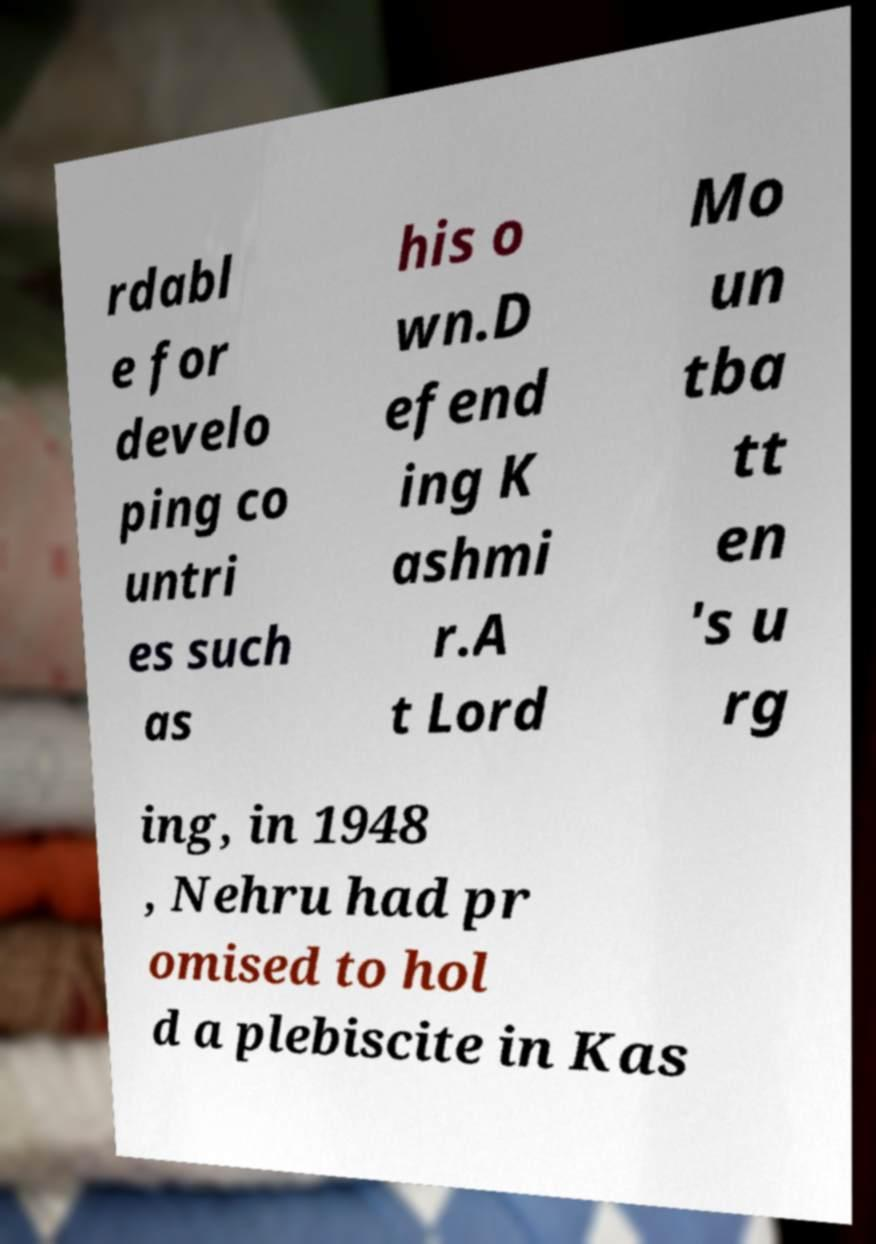What messages or text are displayed in this image? I need them in a readable, typed format. rdabl e for develo ping co untri es such as his o wn.D efend ing K ashmi r.A t Lord Mo un tba tt en 's u rg ing, in 1948 , Nehru had pr omised to hol d a plebiscite in Kas 